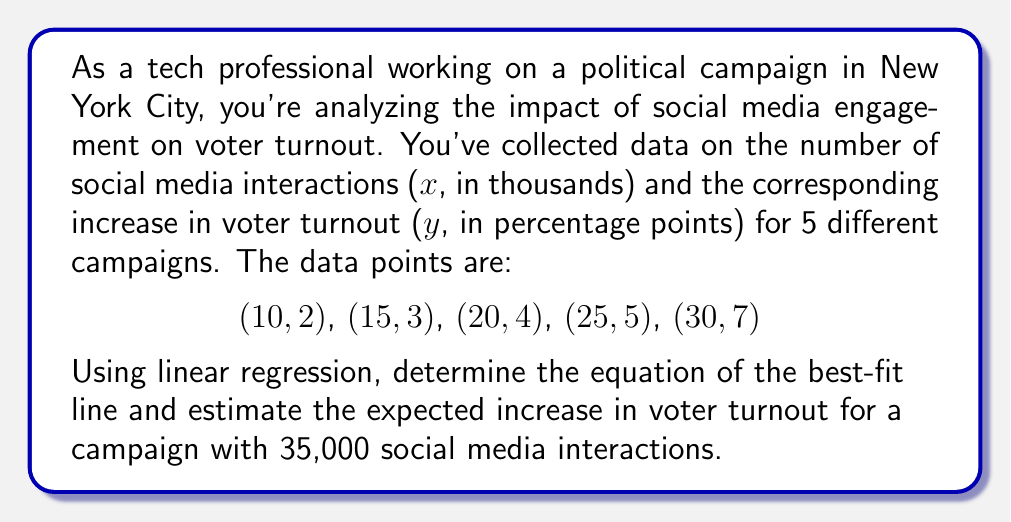Solve this math problem. To solve this problem, we'll use linear regression to find the best-fit line equation and then use it to make a prediction.

Step 1: Calculate the means of x and y
$\bar{x} = \frac{10 + 15 + 20 + 25 + 30}{5} = 20$
$\bar{y} = \frac{2 + 3 + 4 + 5 + 7}{5} = 4.2$

Step 2: Calculate the slope (m) using the formula:
$$m = \frac{\sum(x_i - \bar{x})(y_i - \bar{y})}{\sum(x_i - \bar{x})^2}$$

$\sum(x_i - \bar{x})(y_i - \bar{y}) = (-10)(-2.2) + (-5)(-1.2) + (0)(-0.2) + (5)(0.8) + (10)(2.8) = 62$
$\sum(x_i - \bar{x})^2 = (-10)^2 + (-5)^2 + (0)^2 + (5)^2 + (10)^2 = 250$

$m = \frac{62}{250} = 0.248$

Step 3: Calculate the y-intercept (b) using the formula:
$b = \bar{y} - m\bar{x}$
$b = 4.2 - (0.248)(20) = -0.76$

Step 4: Write the equation of the best-fit line
$y = mx + b$
$y = 0.248x - 0.76$

Step 5: Estimate the increase in voter turnout for 35,000 interactions
$x = 35$ (since x is in thousands)
$y = 0.248(35) - 0.76 = 7.92$

Therefore, the expected increase in voter turnout for a campaign with 35,000 social media interactions is approximately 7.92 percentage points.
Answer: $y = 0.248x - 0.76$; 7.92 percentage points 